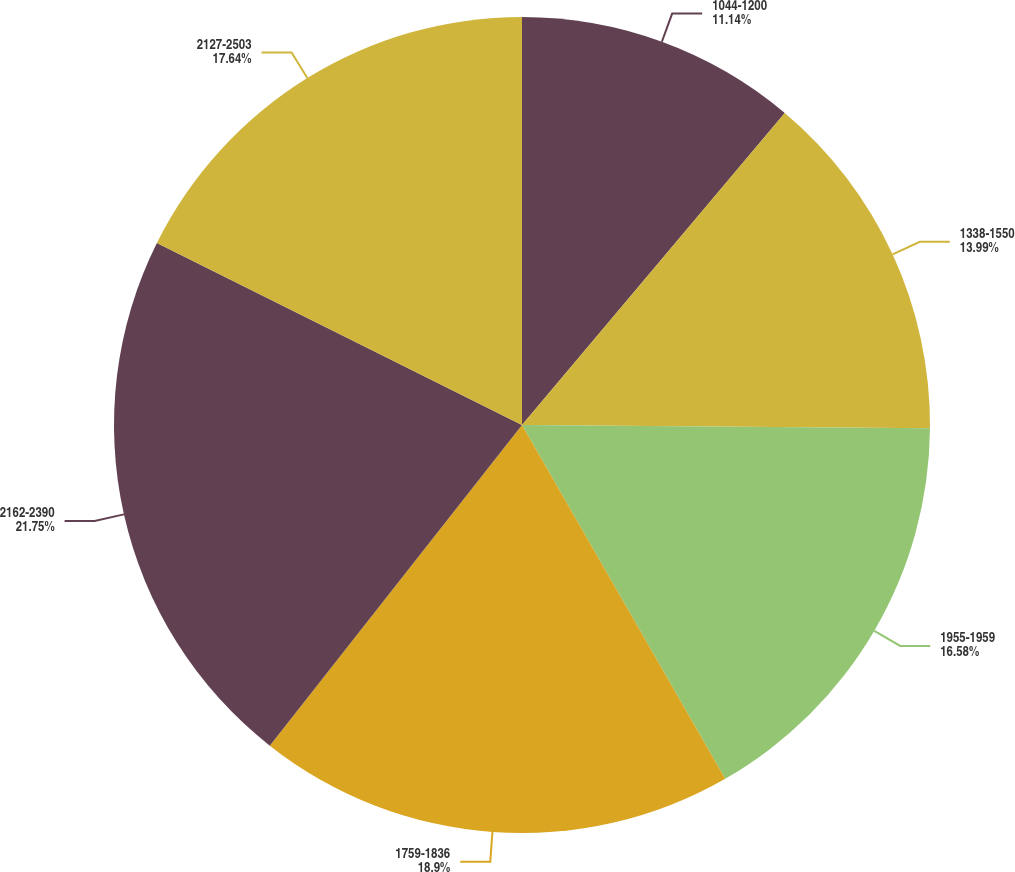Convert chart. <chart><loc_0><loc_0><loc_500><loc_500><pie_chart><fcel>1044-1200<fcel>1338-1550<fcel>1955-1959<fcel>1759-1836<fcel>2162-2390<fcel>2127-2503<nl><fcel>11.14%<fcel>13.99%<fcel>16.58%<fcel>18.91%<fcel>21.76%<fcel>17.64%<nl></chart> 